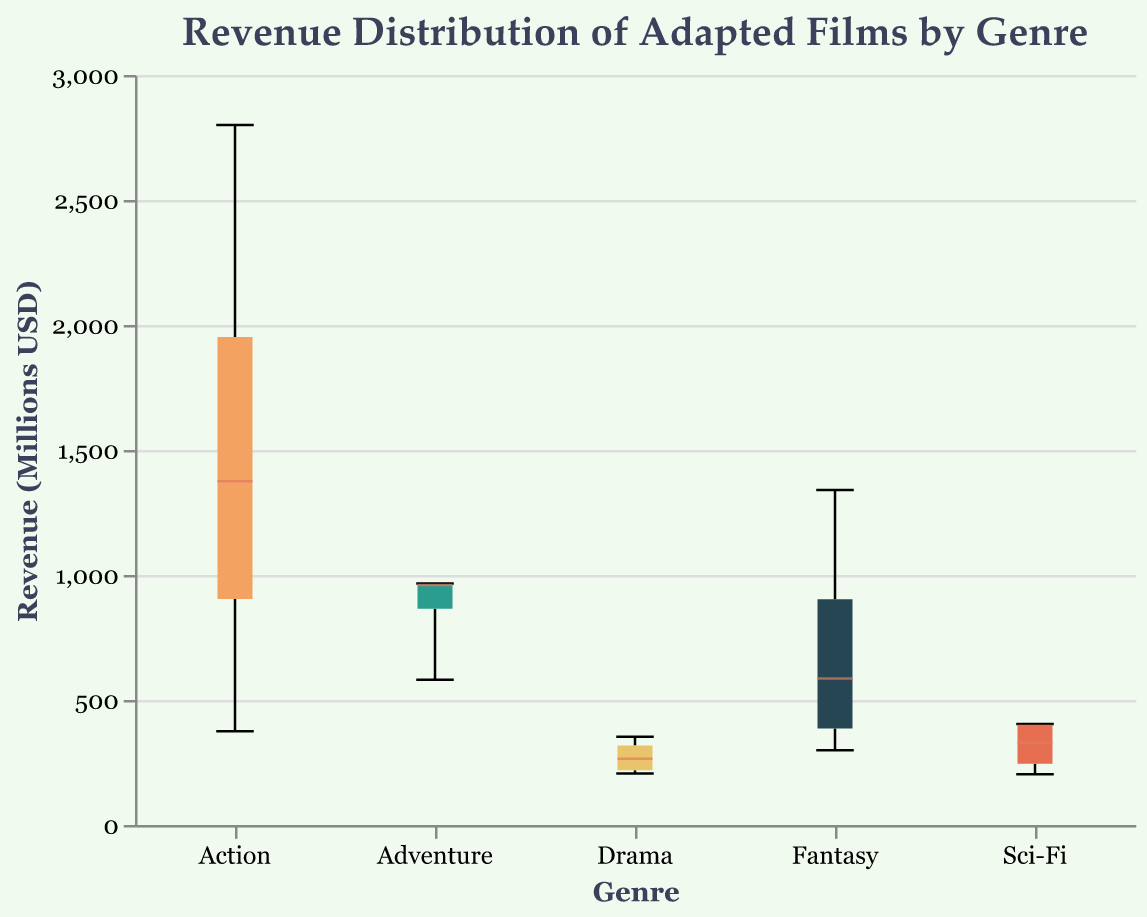What is the title of the plot? The title of the plot can be found at the top of the chart, which describes the content of the visualization. Hence, the title of the plot is "Revenue Distribution of Adapted Films by Genre".
Answer: Revenue Distribution of Adapted Films by Genre What are the genres included in the plot? The genres are represented on the x-axis, each with a distinct color. The genres included in the plot are "Action", "Adventure", "Drama", "Fantasy", and "Sci-Fi".
Answer: Action, Adventure, Drama, Fantasy, Sci-Fi Which genre has the highest median revenue? To find the genre with the highest median revenue, look for the position of the median line (usually the bold line within the box) across all genres. The genre with the highest median line is "Action".
Answer: Action What is the interquartile range (IQR) for the Drama genre? The IQR can be identified as the range between the lower quartile (25th percentile) and the upper quartile (75th percentile) of the box plot for the Drama genre. The lower quartile roughly aligns with $206M and the upper quartile with $353M. So, IQR = $353M - $206M.
Answer: $147M Does the Sci-Fi genre have any outliers? In a box plot, outliers are represented as points outside the whiskers of the box plot. By examining the Sci-Fi genre's box plot, since there are no points outside the whiskers, it does not have any outliers.
Answer: No Which genre has the widest revenue distribution? The width of the revenue distribution can be assessed by comparing the lengths of the whiskers from minimum to maximum values. The genre with the widest revenue distribution is "Action".
Answer: Action What is the median revenue for the Fantasy genre? Locate the median line within the box plot for the Fantasy genre. The median revenue appears to be approximately around $758M.
Answer: $758M Compare the median revenues of Adventure and Drama genres. Which one is higher and by how much? The median revenue for Adventure is around $963M, and for Drama, it's around $265M. To find the difference: $963M - $265M = $698M. Therefore, Adventure has a higher median revenue by $698M.
Answer: Adventure is higher by $698M What is the range of revenues for the Adventure genre? For the range, identify the minimum and maximum values (ends of the whiskers) of the Adventure genre. The minimum revenue is around $581M and the maximum is $966M. The range is $966M - $581M = $385M.
Answer: $385M Is the median revenue for Sci-Fi higher or lower than the overall median? First, estimate the overall median by averaging medians from all genres (not specifically shown, but assume it's represented across the whiskers' medians). Assuming it's around $800M, compare it with Sci-Fi's median of about $310M. Hence, the median for Sci-Fi is lower.
Answer: Lower 